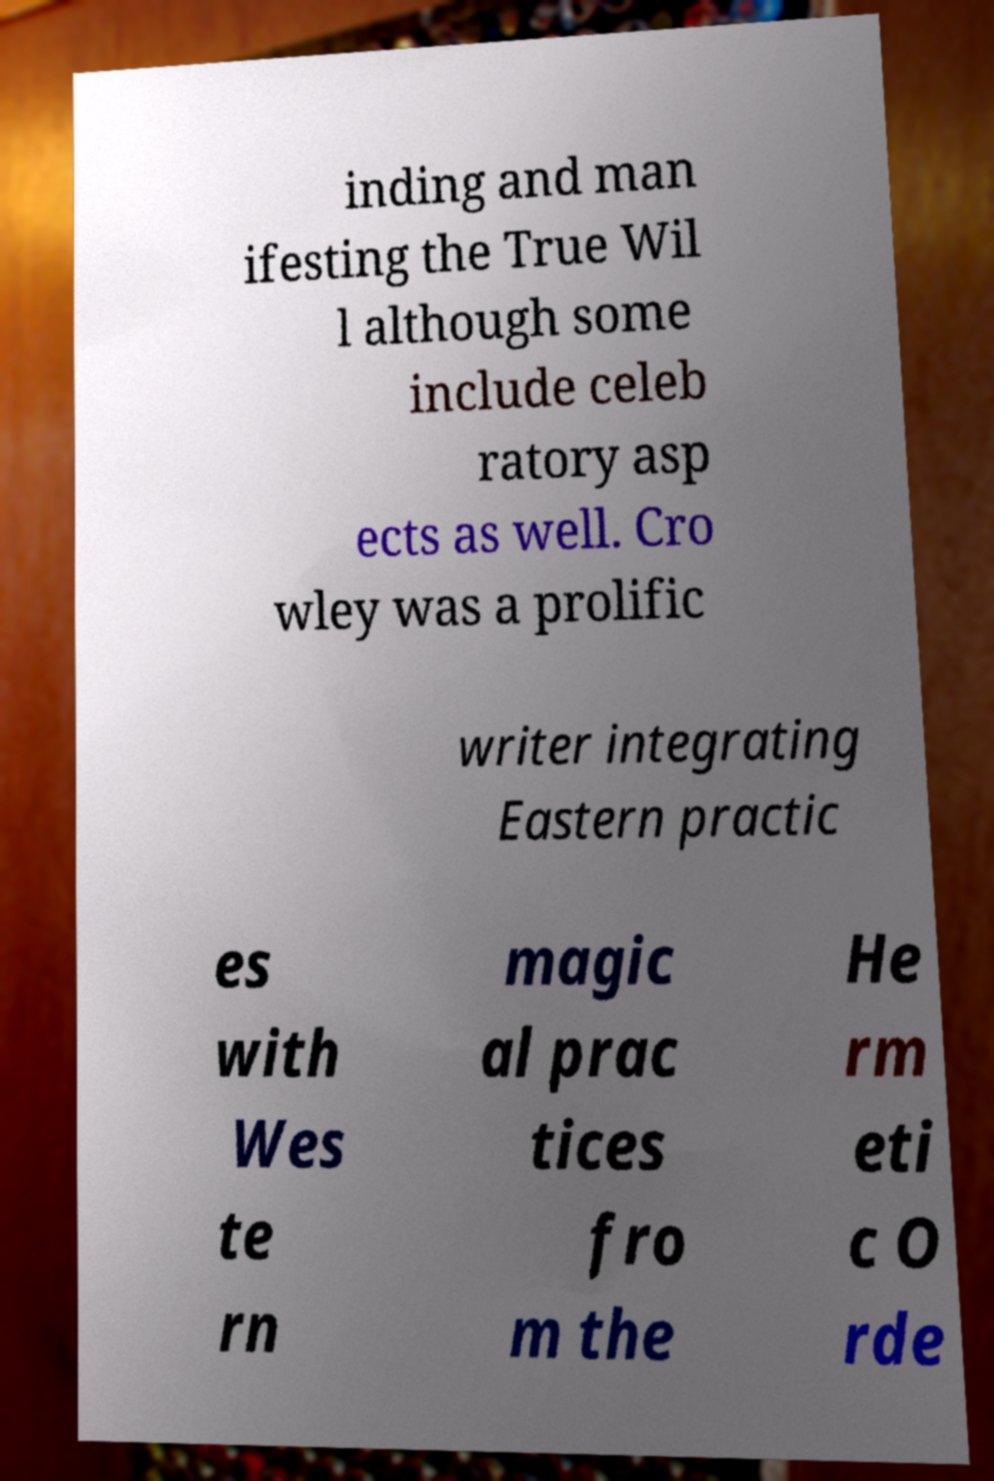Can you read and provide the text displayed in the image?This photo seems to have some interesting text. Can you extract and type it out for me? inding and man ifesting the True Wil l although some include celeb ratory asp ects as well. Cro wley was a prolific writer integrating Eastern practic es with Wes te rn magic al prac tices fro m the He rm eti c O rde 